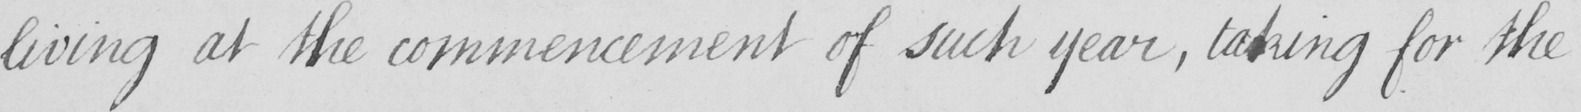Please provide the text content of this handwritten line. living at the commencement of such year , taking for the 